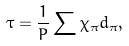Convert formula to latex. <formula><loc_0><loc_0><loc_500><loc_500>\tau = \frac { 1 } { P } \sum \chi _ { \pi } d _ { \pi } ,</formula> 